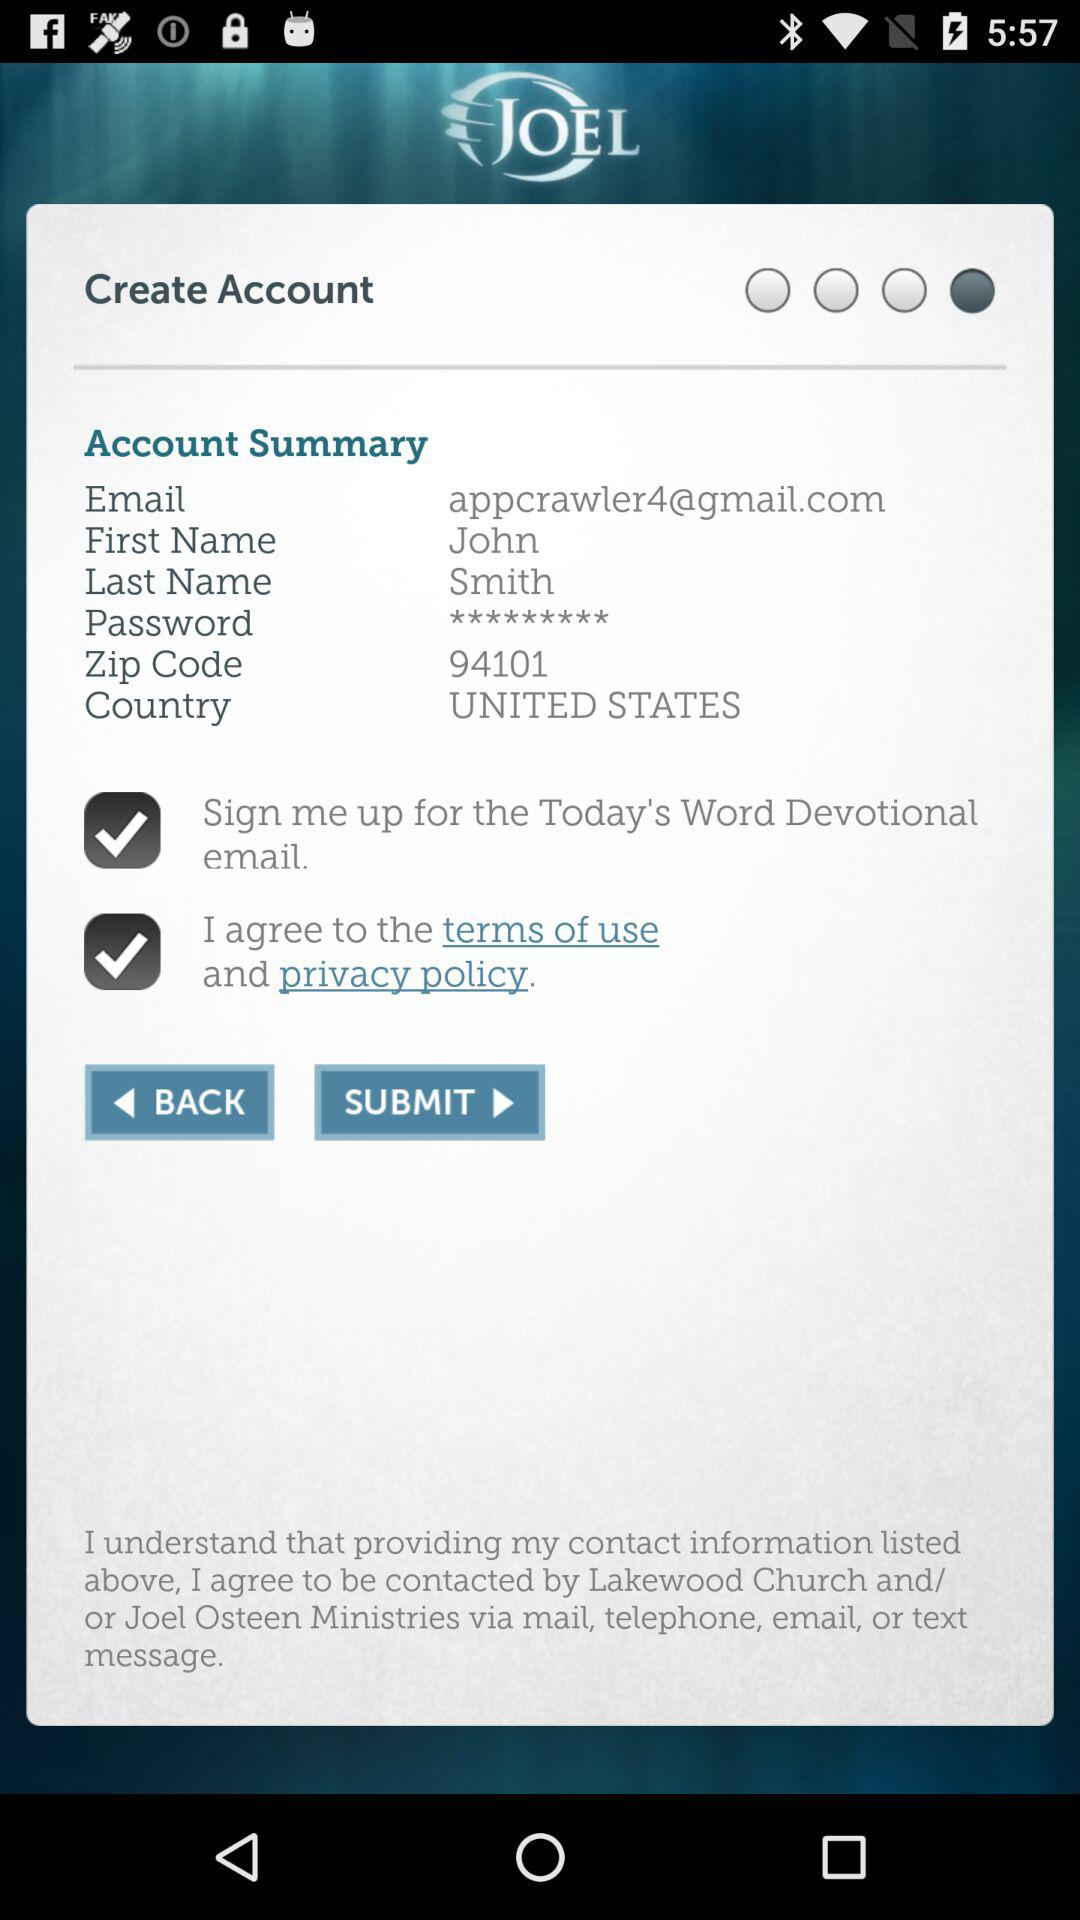What is the last name? The last name is Smith. 